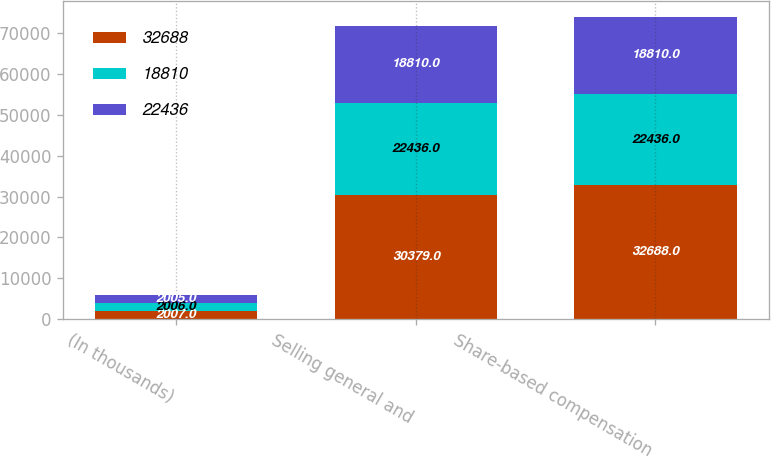Convert chart to OTSL. <chart><loc_0><loc_0><loc_500><loc_500><stacked_bar_chart><ecel><fcel>(In thousands)<fcel>Selling general and<fcel>Share-based compensation<nl><fcel>32688<fcel>2007<fcel>30379<fcel>32688<nl><fcel>18810<fcel>2006<fcel>22436<fcel>22436<nl><fcel>22436<fcel>2005<fcel>18810<fcel>18810<nl></chart> 